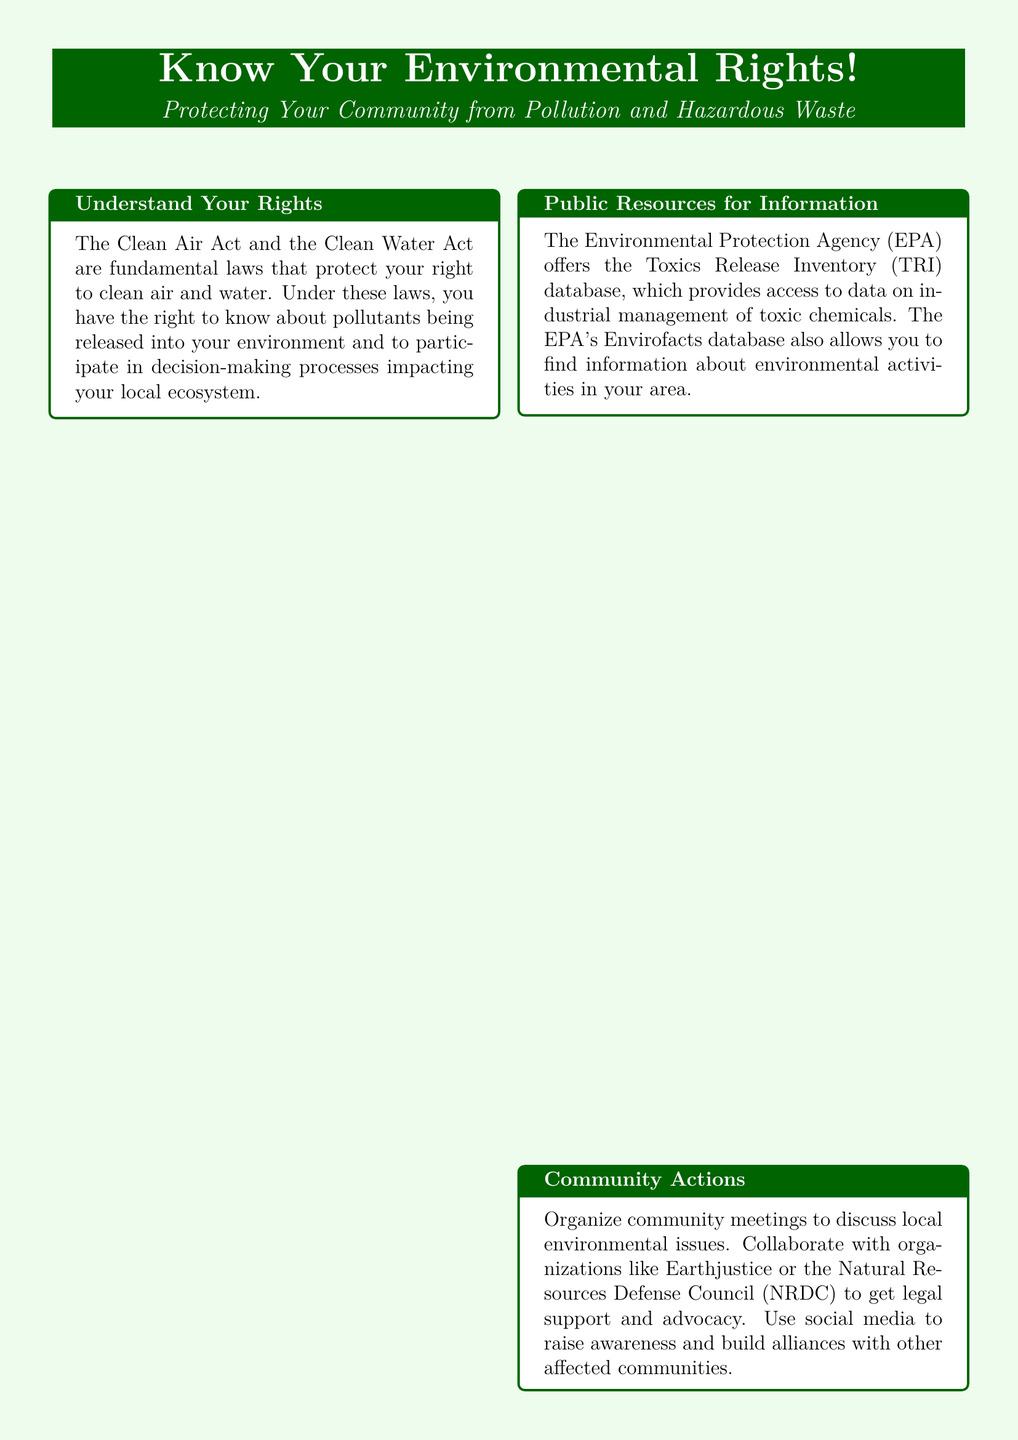What two fundamental laws protect your environmental rights? The document mentions the Clean Air Act and the Clean Water Act as fundamental laws that protect your right to clean air and water.
Answer: Clean Air Act and Clean Water Act What database does the EPA offer for information on toxic chemicals? The document states that the EPA offers the Toxics Release Inventory (TRI) database for information on industrial management of toxic chemicals.
Answer: Toxics Release Inventory (TRI) Which community organizations are suggested for collaboration? The document lists Earthjustice and the Natural Resources Defense Council (NRDC) as organizations to collaborate with for legal support and advocacy.
Answer: Earthjustice and NRDC What should you do if you suspect pollution violations? The document advises filing a complaint with your state's environmental agency or the EPA.
Answer: File a complaint Which city is mentioned as having fought against lead contamination? The document refers to Flint, Michigan, as a community that has successfully brought attention to lead contamination in their water supply.
Answer: Flint, Michigan What is the call to action at the end of the document? The document encourages readers to get involved and know their rights regarding environmental issues.
Answer: Get involved today and know your rights What color is used for the background of the advertisement? The document describes the background color as light green.
Answer: Light green How many columns of information are presented in the document? The document is structured in two columns to present information.
Answer: Two columns What is the primary focus of the advertisement? The advertisement emphasizes knowing environmental rights to protect communities from pollution and hazardous waste.
Answer: Protecting Your Community from Pollution and Hazardous Waste 